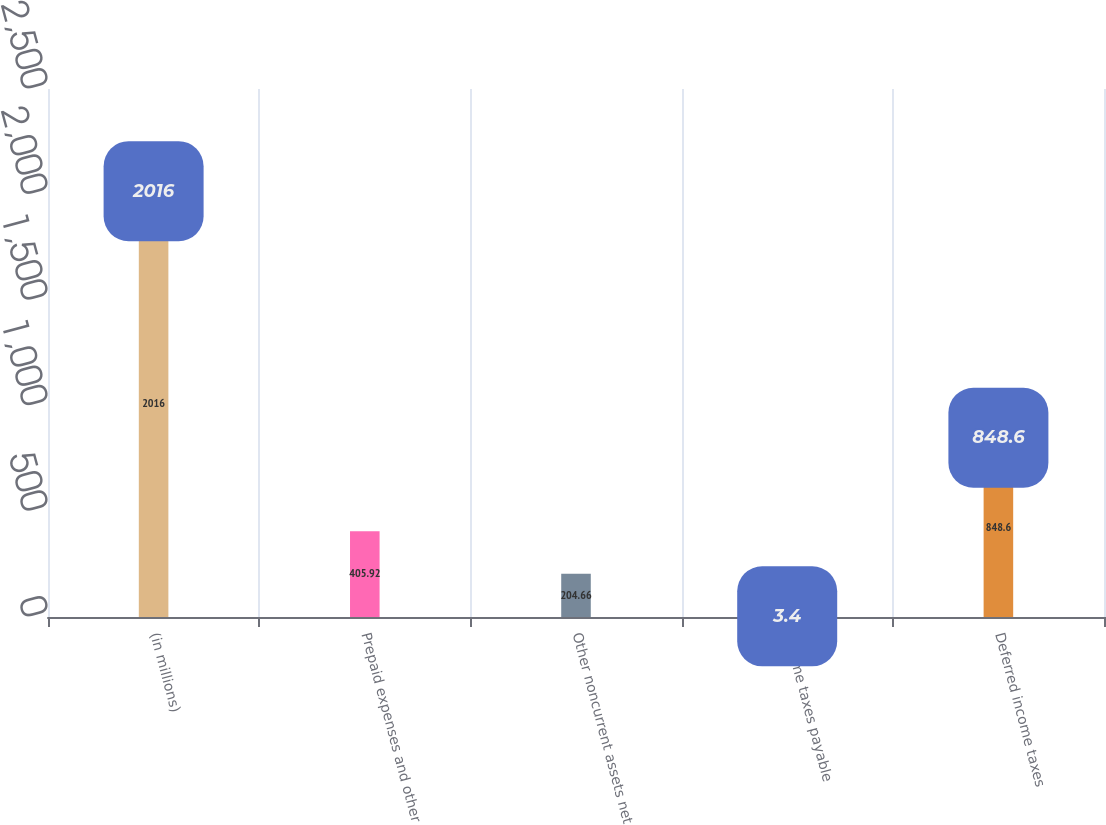<chart> <loc_0><loc_0><loc_500><loc_500><bar_chart><fcel>(in millions)<fcel>Prepaid expenses and other<fcel>Other noncurrent assets net<fcel>Income taxes payable<fcel>Deferred income taxes<nl><fcel>2016<fcel>405.92<fcel>204.66<fcel>3.4<fcel>848.6<nl></chart> 